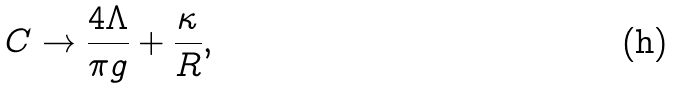<formula> <loc_0><loc_0><loc_500><loc_500>C \to \frac { 4 \Lambda } { \pi g } + \frac { \kappa } { R } ,</formula> 